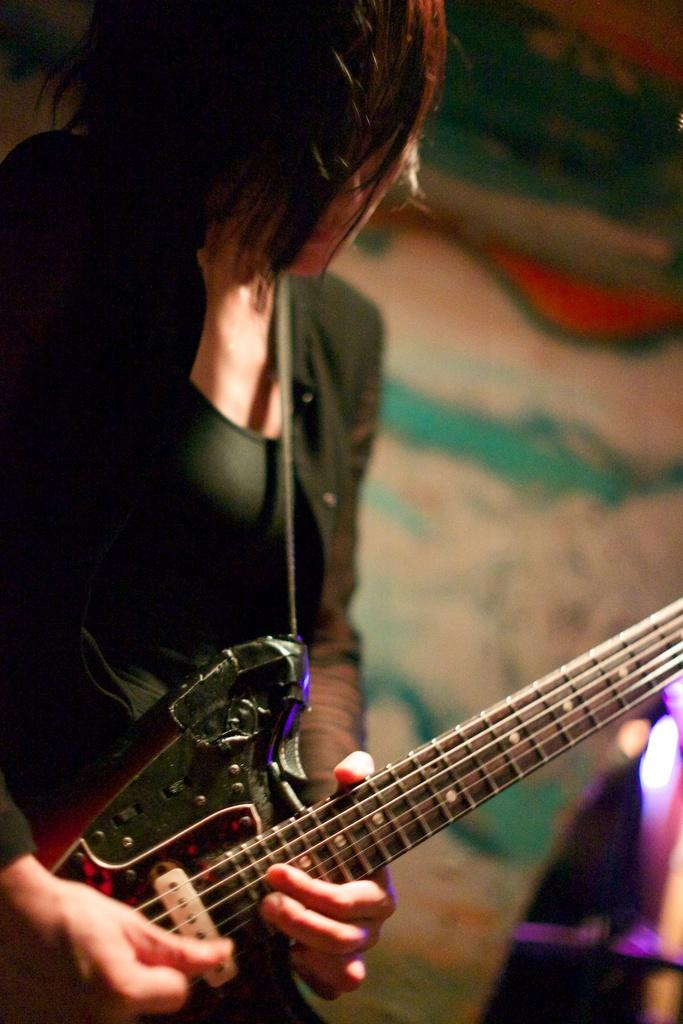What is the person in the image doing? The person is holding a guitar. What object is the person holding in the image? The person is holding a guitar. What can be seen in the background of the image? There is a wall in the background of the image. How does the person in the image try to pull the wall towards them? There is no indication in the image that the person is trying to pull the wall towards them. 